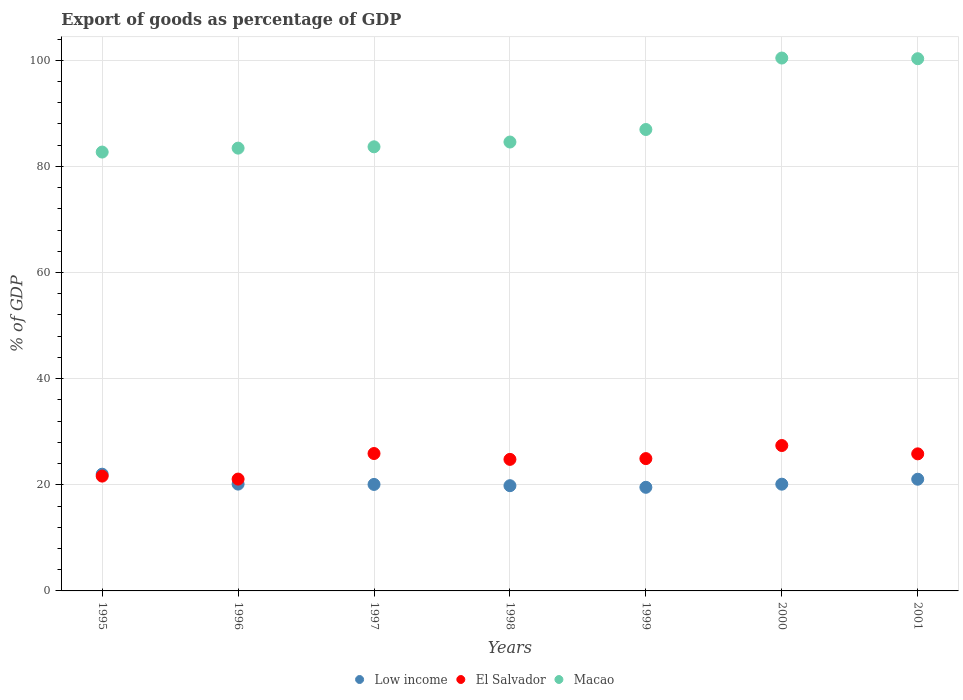What is the export of goods as percentage of GDP in Low income in 1998?
Your response must be concise. 19.83. Across all years, what is the maximum export of goods as percentage of GDP in El Salvador?
Your answer should be compact. 27.4. Across all years, what is the minimum export of goods as percentage of GDP in El Salvador?
Ensure brevity in your answer.  21.08. In which year was the export of goods as percentage of GDP in Macao maximum?
Provide a short and direct response. 2000. In which year was the export of goods as percentage of GDP in Macao minimum?
Keep it short and to the point. 1995. What is the total export of goods as percentage of GDP in Macao in the graph?
Your answer should be compact. 622.11. What is the difference between the export of goods as percentage of GDP in Low income in 2000 and that in 2001?
Ensure brevity in your answer.  -0.94. What is the difference between the export of goods as percentage of GDP in Low income in 1998 and the export of goods as percentage of GDP in El Salvador in 2001?
Keep it short and to the point. -6. What is the average export of goods as percentage of GDP in Low income per year?
Give a very brief answer. 20.39. In the year 1997, what is the difference between the export of goods as percentage of GDP in El Salvador and export of goods as percentage of GDP in Macao?
Offer a terse response. -57.8. In how many years, is the export of goods as percentage of GDP in Macao greater than 48 %?
Your answer should be compact. 7. What is the ratio of the export of goods as percentage of GDP in El Salvador in 1996 to that in 1997?
Ensure brevity in your answer.  0.81. Is the export of goods as percentage of GDP in El Salvador in 1998 less than that in 2000?
Provide a succinct answer. Yes. Is the difference between the export of goods as percentage of GDP in El Salvador in 1995 and 1998 greater than the difference between the export of goods as percentage of GDP in Macao in 1995 and 1998?
Provide a short and direct response. No. What is the difference between the highest and the second highest export of goods as percentage of GDP in Low income?
Your response must be concise. 0.95. What is the difference between the highest and the lowest export of goods as percentage of GDP in El Salvador?
Offer a very short reply. 6.32. In how many years, is the export of goods as percentage of GDP in Macao greater than the average export of goods as percentage of GDP in Macao taken over all years?
Give a very brief answer. 2. Is the sum of the export of goods as percentage of GDP in Macao in 1995 and 1999 greater than the maximum export of goods as percentage of GDP in Low income across all years?
Keep it short and to the point. Yes. Is the export of goods as percentage of GDP in El Salvador strictly greater than the export of goods as percentage of GDP in Macao over the years?
Make the answer very short. No. Is the export of goods as percentage of GDP in El Salvador strictly less than the export of goods as percentage of GDP in Macao over the years?
Offer a very short reply. Yes. How many dotlines are there?
Keep it short and to the point. 3. How many years are there in the graph?
Your response must be concise. 7. How many legend labels are there?
Offer a very short reply. 3. What is the title of the graph?
Keep it short and to the point. Export of goods as percentage of GDP. What is the label or title of the X-axis?
Give a very brief answer. Years. What is the label or title of the Y-axis?
Ensure brevity in your answer.  % of GDP. What is the % of GDP of Low income in 1995?
Your answer should be compact. 22. What is the % of GDP of El Salvador in 1995?
Your answer should be compact. 21.64. What is the % of GDP in Macao in 1995?
Provide a succinct answer. 82.7. What is the % of GDP in Low income in 1996?
Keep it short and to the point. 20.13. What is the % of GDP in El Salvador in 1996?
Your answer should be compact. 21.08. What is the % of GDP in Macao in 1996?
Offer a very short reply. 83.44. What is the % of GDP of Low income in 1997?
Give a very brief answer. 20.07. What is the % of GDP of El Salvador in 1997?
Keep it short and to the point. 25.89. What is the % of GDP in Macao in 1997?
Offer a very short reply. 83.7. What is the % of GDP in Low income in 1998?
Your answer should be compact. 19.83. What is the % of GDP in El Salvador in 1998?
Your answer should be compact. 24.79. What is the % of GDP in Macao in 1998?
Offer a very short reply. 84.6. What is the % of GDP in Low income in 1999?
Keep it short and to the point. 19.53. What is the % of GDP of El Salvador in 1999?
Your answer should be very brief. 24.94. What is the % of GDP in Macao in 1999?
Your response must be concise. 86.96. What is the % of GDP of Low income in 2000?
Ensure brevity in your answer.  20.12. What is the % of GDP of El Salvador in 2000?
Provide a succinct answer. 27.4. What is the % of GDP of Macao in 2000?
Provide a succinct answer. 100.42. What is the % of GDP of Low income in 2001?
Your answer should be compact. 21.05. What is the % of GDP of El Salvador in 2001?
Keep it short and to the point. 25.83. What is the % of GDP in Macao in 2001?
Give a very brief answer. 100.3. Across all years, what is the maximum % of GDP of Low income?
Provide a succinct answer. 22. Across all years, what is the maximum % of GDP in El Salvador?
Keep it short and to the point. 27.4. Across all years, what is the maximum % of GDP of Macao?
Provide a succinct answer. 100.42. Across all years, what is the minimum % of GDP in Low income?
Offer a very short reply. 19.53. Across all years, what is the minimum % of GDP in El Salvador?
Your answer should be very brief. 21.08. Across all years, what is the minimum % of GDP of Macao?
Your answer should be compact. 82.7. What is the total % of GDP of Low income in the graph?
Your response must be concise. 142.72. What is the total % of GDP in El Salvador in the graph?
Ensure brevity in your answer.  171.57. What is the total % of GDP of Macao in the graph?
Keep it short and to the point. 622.11. What is the difference between the % of GDP of Low income in 1995 and that in 1996?
Your response must be concise. 1.87. What is the difference between the % of GDP in El Salvador in 1995 and that in 1996?
Offer a very short reply. 0.56. What is the difference between the % of GDP in Macao in 1995 and that in 1996?
Your response must be concise. -0.74. What is the difference between the % of GDP in Low income in 1995 and that in 1997?
Offer a terse response. 1.93. What is the difference between the % of GDP in El Salvador in 1995 and that in 1997?
Your answer should be very brief. -4.26. What is the difference between the % of GDP of Macao in 1995 and that in 1997?
Make the answer very short. -0.99. What is the difference between the % of GDP of Low income in 1995 and that in 1998?
Offer a terse response. 2.17. What is the difference between the % of GDP in El Salvador in 1995 and that in 1998?
Make the answer very short. -3.15. What is the difference between the % of GDP of Macao in 1995 and that in 1998?
Give a very brief answer. -1.89. What is the difference between the % of GDP of Low income in 1995 and that in 1999?
Ensure brevity in your answer.  2.47. What is the difference between the % of GDP in El Salvador in 1995 and that in 1999?
Ensure brevity in your answer.  -3.3. What is the difference between the % of GDP of Macao in 1995 and that in 1999?
Your answer should be very brief. -4.25. What is the difference between the % of GDP in Low income in 1995 and that in 2000?
Give a very brief answer. 1.88. What is the difference between the % of GDP of El Salvador in 1995 and that in 2000?
Provide a succinct answer. -5.76. What is the difference between the % of GDP in Macao in 1995 and that in 2000?
Give a very brief answer. -17.72. What is the difference between the % of GDP of Low income in 1995 and that in 2001?
Keep it short and to the point. 0.95. What is the difference between the % of GDP in El Salvador in 1995 and that in 2001?
Provide a succinct answer. -4.19. What is the difference between the % of GDP in Macao in 1995 and that in 2001?
Ensure brevity in your answer.  -17.59. What is the difference between the % of GDP of Low income in 1996 and that in 1997?
Your response must be concise. 0.06. What is the difference between the % of GDP in El Salvador in 1996 and that in 1997?
Provide a short and direct response. -4.82. What is the difference between the % of GDP of Macao in 1996 and that in 1997?
Provide a succinct answer. -0.25. What is the difference between the % of GDP in Low income in 1996 and that in 1998?
Give a very brief answer. 0.3. What is the difference between the % of GDP of El Salvador in 1996 and that in 1998?
Your answer should be compact. -3.71. What is the difference between the % of GDP of Macao in 1996 and that in 1998?
Provide a short and direct response. -1.15. What is the difference between the % of GDP in Low income in 1996 and that in 1999?
Give a very brief answer. 0.6. What is the difference between the % of GDP of El Salvador in 1996 and that in 1999?
Provide a short and direct response. -3.86. What is the difference between the % of GDP of Macao in 1996 and that in 1999?
Keep it short and to the point. -3.51. What is the difference between the % of GDP in Low income in 1996 and that in 2000?
Keep it short and to the point. 0.02. What is the difference between the % of GDP of El Salvador in 1996 and that in 2000?
Your answer should be very brief. -6.32. What is the difference between the % of GDP of Macao in 1996 and that in 2000?
Make the answer very short. -16.98. What is the difference between the % of GDP in Low income in 1996 and that in 2001?
Provide a short and direct response. -0.92. What is the difference between the % of GDP in El Salvador in 1996 and that in 2001?
Provide a short and direct response. -4.76. What is the difference between the % of GDP in Macao in 1996 and that in 2001?
Give a very brief answer. -16.85. What is the difference between the % of GDP in Low income in 1997 and that in 1998?
Provide a succinct answer. 0.24. What is the difference between the % of GDP of El Salvador in 1997 and that in 1998?
Keep it short and to the point. 1.1. What is the difference between the % of GDP of Macao in 1997 and that in 1998?
Your response must be concise. -0.9. What is the difference between the % of GDP of Low income in 1997 and that in 1999?
Your response must be concise. 0.54. What is the difference between the % of GDP in El Salvador in 1997 and that in 1999?
Ensure brevity in your answer.  0.96. What is the difference between the % of GDP in Macao in 1997 and that in 1999?
Provide a short and direct response. -3.26. What is the difference between the % of GDP of Low income in 1997 and that in 2000?
Your answer should be very brief. -0.05. What is the difference between the % of GDP of El Salvador in 1997 and that in 2000?
Ensure brevity in your answer.  -1.51. What is the difference between the % of GDP in Macao in 1997 and that in 2000?
Keep it short and to the point. -16.73. What is the difference between the % of GDP in Low income in 1997 and that in 2001?
Provide a short and direct response. -0.98. What is the difference between the % of GDP of El Salvador in 1997 and that in 2001?
Give a very brief answer. 0.06. What is the difference between the % of GDP of Macao in 1997 and that in 2001?
Your answer should be compact. -16.6. What is the difference between the % of GDP of Low income in 1998 and that in 1999?
Offer a very short reply. 0.3. What is the difference between the % of GDP of El Salvador in 1998 and that in 1999?
Keep it short and to the point. -0.15. What is the difference between the % of GDP of Macao in 1998 and that in 1999?
Provide a succinct answer. -2.36. What is the difference between the % of GDP in Low income in 1998 and that in 2000?
Offer a terse response. -0.28. What is the difference between the % of GDP in El Salvador in 1998 and that in 2000?
Your response must be concise. -2.61. What is the difference between the % of GDP in Macao in 1998 and that in 2000?
Provide a succinct answer. -15.83. What is the difference between the % of GDP of Low income in 1998 and that in 2001?
Ensure brevity in your answer.  -1.22. What is the difference between the % of GDP in El Salvador in 1998 and that in 2001?
Give a very brief answer. -1.04. What is the difference between the % of GDP of Macao in 1998 and that in 2001?
Make the answer very short. -15.7. What is the difference between the % of GDP of Low income in 1999 and that in 2000?
Give a very brief answer. -0.59. What is the difference between the % of GDP of El Salvador in 1999 and that in 2000?
Your response must be concise. -2.46. What is the difference between the % of GDP in Macao in 1999 and that in 2000?
Provide a short and direct response. -13.47. What is the difference between the % of GDP of Low income in 1999 and that in 2001?
Offer a very short reply. -1.52. What is the difference between the % of GDP of El Salvador in 1999 and that in 2001?
Keep it short and to the point. -0.9. What is the difference between the % of GDP of Macao in 1999 and that in 2001?
Offer a terse response. -13.34. What is the difference between the % of GDP of Low income in 2000 and that in 2001?
Give a very brief answer. -0.94. What is the difference between the % of GDP in El Salvador in 2000 and that in 2001?
Your answer should be very brief. 1.57. What is the difference between the % of GDP in Macao in 2000 and that in 2001?
Offer a very short reply. 0.13. What is the difference between the % of GDP in Low income in 1995 and the % of GDP in El Salvador in 1996?
Give a very brief answer. 0.92. What is the difference between the % of GDP in Low income in 1995 and the % of GDP in Macao in 1996?
Make the answer very short. -61.45. What is the difference between the % of GDP in El Salvador in 1995 and the % of GDP in Macao in 1996?
Your answer should be compact. -61.81. What is the difference between the % of GDP in Low income in 1995 and the % of GDP in El Salvador in 1997?
Keep it short and to the point. -3.9. What is the difference between the % of GDP in Low income in 1995 and the % of GDP in Macao in 1997?
Give a very brief answer. -61.7. What is the difference between the % of GDP in El Salvador in 1995 and the % of GDP in Macao in 1997?
Your response must be concise. -62.06. What is the difference between the % of GDP in Low income in 1995 and the % of GDP in El Salvador in 1998?
Give a very brief answer. -2.79. What is the difference between the % of GDP of Low income in 1995 and the % of GDP of Macao in 1998?
Your answer should be compact. -62.6. What is the difference between the % of GDP in El Salvador in 1995 and the % of GDP in Macao in 1998?
Your response must be concise. -62.96. What is the difference between the % of GDP of Low income in 1995 and the % of GDP of El Salvador in 1999?
Provide a succinct answer. -2.94. What is the difference between the % of GDP in Low income in 1995 and the % of GDP in Macao in 1999?
Provide a succinct answer. -64.96. What is the difference between the % of GDP in El Salvador in 1995 and the % of GDP in Macao in 1999?
Keep it short and to the point. -65.32. What is the difference between the % of GDP in Low income in 1995 and the % of GDP in El Salvador in 2000?
Give a very brief answer. -5.4. What is the difference between the % of GDP of Low income in 1995 and the % of GDP of Macao in 2000?
Make the answer very short. -78.42. What is the difference between the % of GDP of El Salvador in 1995 and the % of GDP of Macao in 2000?
Your answer should be compact. -78.79. What is the difference between the % of GDP of Low income in 1995 and the % of GDP of El Salvador in 2001?
Keep it short and to the point. -3.83. What is the difference between the % of GDP of Low income in 1995 and the % of GDP of Macao in 2001?
Make the answer very short. -78.3. What is the difference between the % of GDP in El Salvador in 1995 and the % of GDP in Macao in 2001?
Keep it short and to the point. -78.66. What is the difference between the % of GDP of Low income in 1996 and the % of GDP of El Salvador in 1997?
Your answer should be very brief. -5.76. What is the difference between the % of GDP in Low income in 1996 and the % of GDP in Macao in 1997?
Provide a short and direct response. -63.56. What is the difference between the % of GDP in El Salvador in 1996 and the % of GDP in Macao in 1997?
Ensure brevity in your answer.  -62.62. What is the difference between the % of GDP of Low income in 1996 and the % of GDP of El Salvador in 1998?
Provide a short and direct response. -4.66. What is the difference between the % of GDP of Low income in 1996 and the % of GDP of Macao in 1998?
Give a very brief answer. -64.46. What is the difference between the % of GDP of El Salvador in 1996 and the % of GDP of Macao in 1998?
Offer a very short reply. -63.52. What is the difference between the % of GDP of Low income in 1996 and the % of GDP of El Salvador in 1999?
Provide a short and direct response. -4.8. What is the difference between the % of GDP in Low income in 1996 and the % of GDP in Macao in 1999?
Your response must be concise. -66.82. What is the difference between the % of GDP of El Salvador in 1996 and the % of GDP of Macao in 1999?
Provide a short and direct response. -65.88. What is the difference between the % of GDP in Low income in 1996 and the % of GDP in El Salvador in 2000?
Make the answer very short. -7.27. What is the difference between the % of GDP of Low income in 1996 and the % of GDP of Macao in 2000?
Provide a succinct answer. -80.29. What is the difference between the % of GDP of El Salvador in 1996 and the % of GDP of Macao in 2000?
Give a very brief answer. -79.35. What is the difference between the % of GDP of Low income in 1996 and the % of GDP of El Salvador in 2001?
Give a very brief answer. -5.7. What is the difference between the % of GDP in Low income in 1996 and the % of GDP in Macao in 2001?
Provide a succinct answer. -80.17. What is the difference between the % of GDP in El Salvador in 1996 and the % of GDP in Macao in 2001?
Offer a terse response. -79.22. What is the difference between the % of GDP in Low income in 1997 and the % of GDP in El Salvador in 1998?
Offer a very short reply. -4.72. What is the difference between the % of GDP in Low income in 1997 and the % of GDP in Macao in 1998?
Keep it short and to the point. -64.53. What is the difference between the % of GDP of El Salvador in 1997 and the % of GDP of Macao in 1998?
Make the answer very short. -58.7. What is the difference between the % of GDP of Low income in 1997 and the % of GDP of El Salvador in 1999?
Offer a very short reply. -4.87. What is the difference between the % of GDP of Low income in 1997 and the % of GDP of Macao in 1999?
Keep it short and to the point. -66.89. What is the difference between the % of GDP in El Salvador in 1997 and the % of GDP in Macao in 1999?
Your answer should be compact. -61.06. What is the difference between the % of GDP of Low income in 1997 and the % of GDP of El Salvador in 2000?
Ensure brevity in your answer.  -7.33. What is the difference between the % of GDP of Low income in 1997 and the % of GDP of Macao in 2000?
Ensure brevity in your answer.  -80.35. What is the difference between the % of GDP of El Salvador in 1997 and the % of GDP of Macao in 2000?
Offer a terse response. -74.53. What is the difference between the % of GDP in Low income in 1997 and the % of GDP in El Salvador in 2001?
Your answer should be very brief. -5.76. What is the difference between the % of GDP of Low income in 1997 and the % of GDP of Macao in 2001?
Offer a very short reply. -80.23. What is the difference between the % of GDP of El Salvador in 1997 and the % of GDP of Macao in 2001?
Offer a terse response. -74.4. What is the difference between the % of GDP in Low income in 1998 and the % of GDP in El Salvador in 1999?
Give a very brief answer. -5.1. What is the difference between the % of GDP in Low income in 1998 and the % of GDP in Macao in 1999?
Give a very brief answer. -67.12. What is the difference between the % of GDP of El Salvador in 1998 and the % of GDP of Macao in 1999?
Make the answer very short. -62.17. What is the difference between the % of GDP in Low income in 1998 and the % of GDP in El Salvador in 2000?
Ensure brevity in your answer.  -7.57. What is the difference between the % of GDP in Low income in 1998 and the % of GDP in Macao in 2000?
Make the answer very short. -80.59. What is the difference between the % of GDP of El Salvador in 1998 and the % of GDP of Macao in 2000?
Offer a very short reply. -75.63. What is the difference between the % of GDP of Low income in 1998 and the % of GDP of El Salvador in 2001?
Your answer should be compact. -6. What is the difference between the % of GDP in Low income in 1998 and the % of GDP in Macao in 2001?
Provide a succinct answer. -80.47. What is the difference between the % of GDP in El Salvador in 1998 and the % of GDP in Macao in 2001?
Keep it short and to the point. -75.51. What is the difference between the % of GDP of Low income in 1999 and the % of GDP of El Salvador in 2000?
Your response must be concise. -7.87. What is the difference between the % of GDP in Low income in 1999 and the % of GDP in Macao in 2000?
Offer a terse response. -80.9. What is the difference between the % of GDP in El Salvador in 1999 and the % of GDP in Macao in 2000?
Provide a short and direct response. -75.49. What is the difference between the % of GDP of Low income in 1999 and the % of GDP of El Salvador in 2001?
Ensure brevity in your answer.  -6.3. What is the difference between the % of GDP of Low income in 1999 and the % of GDP of Macao in 2001?
Offer a terse response. -80.77. What is the difference between the % of GDP of El Salvador in 1999 and the % of GDP of Macao in 2001?
Provide a succinct answer. -75.36. What is the difference between the % of GDP in Low income in 2000 and the % of GDP in El Salvador in 2001?
Offer a very short reply. -5.72. What is the difference between the % of GDP of Low income in 2000 and the % of GDP of Macao in 2001?
Your answer should be compact. -80.18. What is the difference between the % of GDP in El Salvador in 2000 and the % of GDP in Macao in 2001?
Offer a terse response. -72.9. What is the average % of GDP of Low income per year?
Ensure brevity in your answer.  20.39. What is the average % of GDP of El Salvador per year?
Keep it short and to the point. 24.51. What is the average % of GDP in Macao per year?
Your answer should be compact. 88.87. In the year 1995, what is the difference between the % of GDP in Low income and % of GDP in El Salvador?
Provide a short and direct response. 0.36. In the year 1995, what is the difference between the % of GDP in Low income and % of GDP in Macao?
Offer a terse response. -60.71. In the year 1995, what is the difference between the % of GDP of El Salvador and % of GDP of Macao?
Ensure brevity in your answer.  -61.07. In the year 1996, what is the difference between the % of GDP of Low income and % of GDP of El Salvador?
Make the answer very short. -0.95. In the year 1996, what is the difference between the % of GDP of Low income and % of GDP of Macao?
Give a very brief answer. -63.31. In the year 1996, what is the difference between the % of GDP of El Salvador and % of GDP of Macao?
Offer a terse response. -62.37. In the year 1997, what is the difference between the % of GDP in Low income and % of GDP in El Salvador?
Offer a very short reply. -5.82. In the year 1997, what is the difference between the % of GDP of Low income and % of GDP of Macao?
Offer a very short reply. -63.63. In the year 1997, what is the difference between the % of GDP of El Salvador and % of GDP of Macao?
Give a very brief answer. -57.8. In the year 1998, what is the difference between the % of GDP in Low income and % of GDP in El Salvador?
Offer a terse response. -4.96. In the year 1998, what is the difference between the % of GDP of Low income and % of GDP of Macao?
Your answer should be very brief. -64.76. In the year 1998, what is the difference between the % of GDP of El Salvador and % of GDP of Macao?
Make the answer very short. -59.81. In the year 1999, what is the difference between the % of GDP of Low income and % of GDP of El Salvador?
Your answer should be very brief. -5.41. In the year 1999, what is the difference between the % of GDP of Low income and % of GDP of Macao?
Provide a short and direct response. -67.43. In the year 1999, what is the difference between the % of GDP of El Salvador and % of GDP of Macao?
Your response must be concise. -62.02. In the year 2000, what is the difference between the % of GDP in Low income and % of GDP in El Salvador?
Your response must be concise. -7.29. In the year 2000, what is the difference between the % of GDP of Low income and % of GDP of Macao?
Provide a short and direct response. -80.31. In the year 2000, what is the difference between the % of GDP in El Salvador and % of GDP in Macao?
Your answer should be very brief. -73.02. In the year 2001, what is the difference between the % of GDP of Low income and % of GDP of El Salvador?
Your answer should be very brief. -4.78. In the year 2001, what is the difference between the % of GDP of Low income and % of GDP of Macao?
Ensure brevity in your answer.  -79.25. In the year 2001, what is the difference between the % of GDP of El Salvador and % of GDP of Macao?
Give a very brief answer. -74.47. What is the ratio of the % of GDP in Low income in 1995 to that in 1996?
Your answer should be very brief. 1.09. What is the ratio of the % of GDP of El Salvador in 1995 to that in 1996?
Provide a succinct answer. 1.03. What is the ratio of the % of GDP in Macao in 1995 to that in 1996?
Make the answer very short. 0.99. What is the ratio of the % of GDP in Low income in 1995 to that in 1997?
Provide a succinct answer. 1.1. What is the ratio of the % of GDP in El Salvador in 1995 to that in 1997?
Provide a succinct answer. 0.84. What is the ratio of the % of GDP of Macao in 1995 to that in 1997?
Offer a very short reply. 0.99. What is the ratio of the % of GDP in Low income in 1995 to that in 1998?
Provide a short and direct response. 1.11. What is the ratio of the % of GDP in El Salvador in 1995 to that in 1998?
Make the answer very short. 0.87. What is the ratio of the % of GDP in Macao in 1995 to that in 1998?
Offer a terse response. 0.98. What is the ratio of the % of GDP in Low income in 1995 to that in 1999?
Provide a short and direct response. 1.13. What is the ratio of the % of GDP in El Salvador in 1995 to that in 1999?
Your answer should be compact. 0.87. What is the ratio of the % of GDP of Macao in 1995 to that in 1999?
Offer a very short reply. 0.95. What is the ratio of the % of GDP of Low income in 1995 to that in 2000?
Offer a very short reply. 1.09. What is the ratio of the % of GDP of El Salvador in 1995 to that in 2000?
Give a very brief answer. 0.79. What is the ratio of the % of GDP of Macao in 1995 to that in 2000?
Ensure brevity in your answer.  0.82. What is the ratio of the % of GDP in Low income in 1995 to that in 2001?
Your answer should be compact. 1.04. What is the ratio of the % of GDP of El Salvador in 1995 to that in 2001?
Keep it short and to the point. 0.84. What is the ratio of the % of GDP in Macao in 1995 to that in 2001?
Ensure brevity in your answer.  0.82. What is the ratio of the % of GDP in El Salvador in 1996 to that in 1997?
Your answer should be compact. 0.81. What is the ratio of the % of GDP of Macao in 1996 to that in 1997?
Provide a succinct answer. 1. What is the ratio of the % of GDP in Low income in 1996 to that in 1998?
Ensure brevity in your answer.  1.02. What is the ratio of the % of GDP of El Salvador in 1996 to that in 1998?
Your answer should be very brief. 0.85. What is the ratio of the % of GDP in Macao in 1996 to that in 1998?
Offer a terse response. 0.99. What is the ratio of the % of GDP in Low income in 1996 to that in 1999?
Provide a short and direct response. 1.03. What is the ratio of the % of GDP in El Salvador in 1996 to that in 1999?
Offer a very short reply. 0.85. What is the ratio of the % of GDP in Macao in 1996 to that in 1999?
Your answer should be very brief. 0.96. What is the ratio of the % of GDP in Low income in 1996 to that in 2000?
Provide a short and direct response. 1. What is the ratio of the % of GDP of El Salvador in 1996 to that in 2000?
Offer a terse response. 0.77. What is the ratio of the % of GDP in Macao in 1996 to that in 2000?
Offer a very short reply. 0.83. What is the ratio of the % of GDP in Low income in 1996 to that in 2001?
Give a very brief answer. 0.96. What is the ratio of the % of GDP in El Salvador in 1996 to that in 2001?
Your answer should be compact. 0.82. What is the ratio of the % of GDP in Macao in 1996 to that in 2001?
Keep it short and to the point. 0.83. What is the ratio of the % of GDP in Low income in 1997 to that in 1998?
Provide a succinct answer. 1.01. What is the ratio of the % of GDP in El Salvador in 1997 to that in 1998?
Give a very brief answer. 1.04. What is the ratio of the % of GDP of Low income in 1997 to that in 1999?
Your answer should be compact. 1.03. What is the ratio of the % of GDP in El Salvador in 1997 to that in 1999?
Offer a very short reply. 1.04. What is the ratio of the % of GDP of Macao in 1997 to that in 1999?
Provide a succinct answer. 0.96. What is the ratio of the % of GDP of Low income in 1997 to that in 2000?
Give a very brief answer. 1. What is the ratio of the % of GDP of El Salvador in 1997 to that in 2000?
Your response must be concise. 0.94. What is the ratio of the % of GDP of Macao in 1997 to that in 2000?
Make the answer very short. 0.83. What is the ratio of the % of GDP of Low income in 1997 to that in 2001?
Your response must be concise. 0.95. What is the ratio of the % of GDP in El Salvador in 1997 to that in 2001?
Keep it short and to the point. 1. What is the ratio of the % of GDP in Macao in 1997 to that in 2001?
Make the answer very short. 0.83. What is the ratio of the % of GDP in Low income in 1998 to that in 1999?
Give a very brief answer. 1.02. What is the ratio of the % of GDP of El Salvador in 1998 to that in 1999?
Your response must be concise. 0.99. What is the ratio of the % of GDP of Macao in 1998 to that in 1999?
Keep it short and to the point. 0.97. What is the ratio of the % of GDP in Low income in 1998 to that in 2000?
Provide a succinct answer. 0.99. What is the ratio of the % of GDP of El Salvador in 1998 to that in 2000?
Ensure brevity in your answer.  0.9. What is the ratio of the % of GDP of Macao in 1998 to that in 2000?
Offer a very short reply. 0.84. What is the ratio of the % of GDP of Low income in 1998 to that in 2001?
Make the answer very short. 0.94. What is the ratio of the % of GDP of El Salvador in 1998 to that in 2001?
Keep it short and to the point. 0.96. What is the ratio of the % of GDP of Macao in 1998 to that in 2001?
Offer a terse response. 0.84. What is the ratio of the % of GDP of Low income in 1999 to that in 2000?
Your answer should be very brief. 0.97. What is the ratio of the % of GDP of El Salvador in 1999 to that in 2000?
Your answer should be compact. 0.91. What is the ratio of the % of GDP of Macao in 1999 to that in 2000?
Your answer should be very brief. 0.87. What is the ratio of the % of GDP in Low income in 1999 to that in 2001?
Your response must be concise. 0.93. What is the ratio of the % of GDP in El Salvador in 1999 to that in 2001?
Your response must be concise. 0.97. What is the ratio of the % of GDP in Macao in 1999 to that in 2001?
Your answer should be compact. 0.87. What is the ratio of the % of GDP in Low income in 2000 to that in 2001?
Give a very brief answer. 0.96. What is the ratio of the % of GDP of El Salvador in 2000 to that in 2001?
Offer a terse response. 1.06. What is the ratio of the % of GDP in Macao in 2000 to that in 2001?
Offer a terse response. 1. What is the difference between the highest and the second highest % of GDP of Low income?
Offer a very short reply. 0.95. What is the difference between the highest and the second highest % of GDP in El Salvador?
Ensure brevity in your answer.  1.51. What is the difference between the highest and the second highest % of GDP in Macao?
Provide a succinct answer. 0.13. What is the difference between the highest and the lowest % of GDP in Low income?
Your answer should be very brief. 2.47. What is the difference between the highest and the lowest % of GDP of El Salvador?
Offer a terse response. 6.32. What is the difference between the highest and the lowest % of GDP of Macao?
Keep it short and to the point. 17.72. 